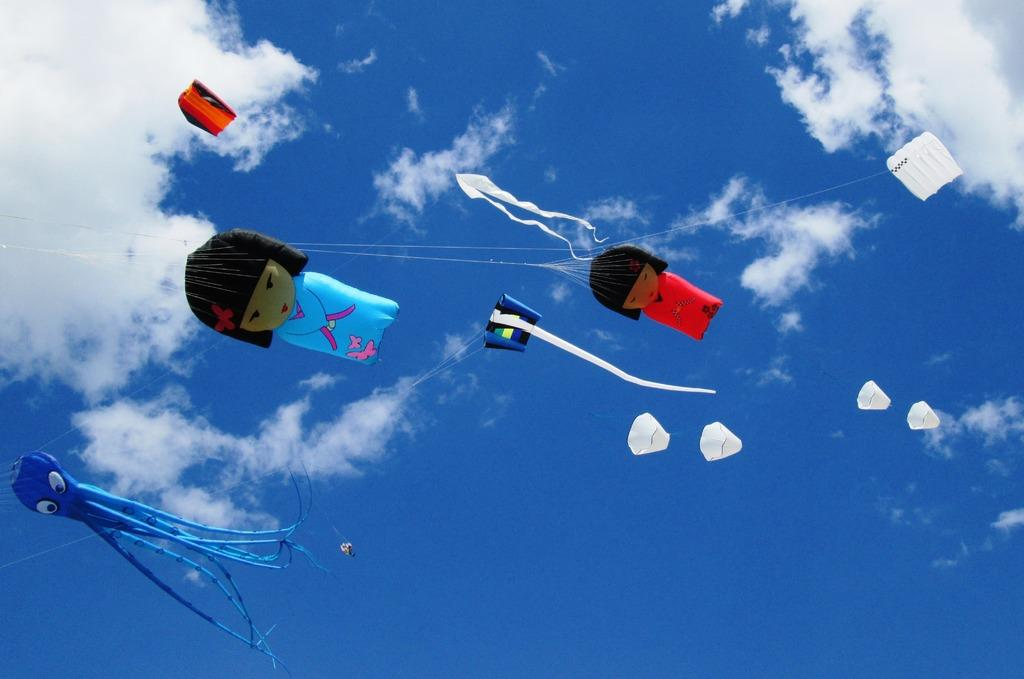What objects are visible in the image that are related to flying? There are kites with threads in the image. What is visible in the background of the image? The sky is visible in the image. What can be seen in the sky? Clouds are present in the sky. What type of noise can be heard coming from the jar in the image? There is no jar present in the image, so it is not possible to determine what, if any, noise might be heard. 